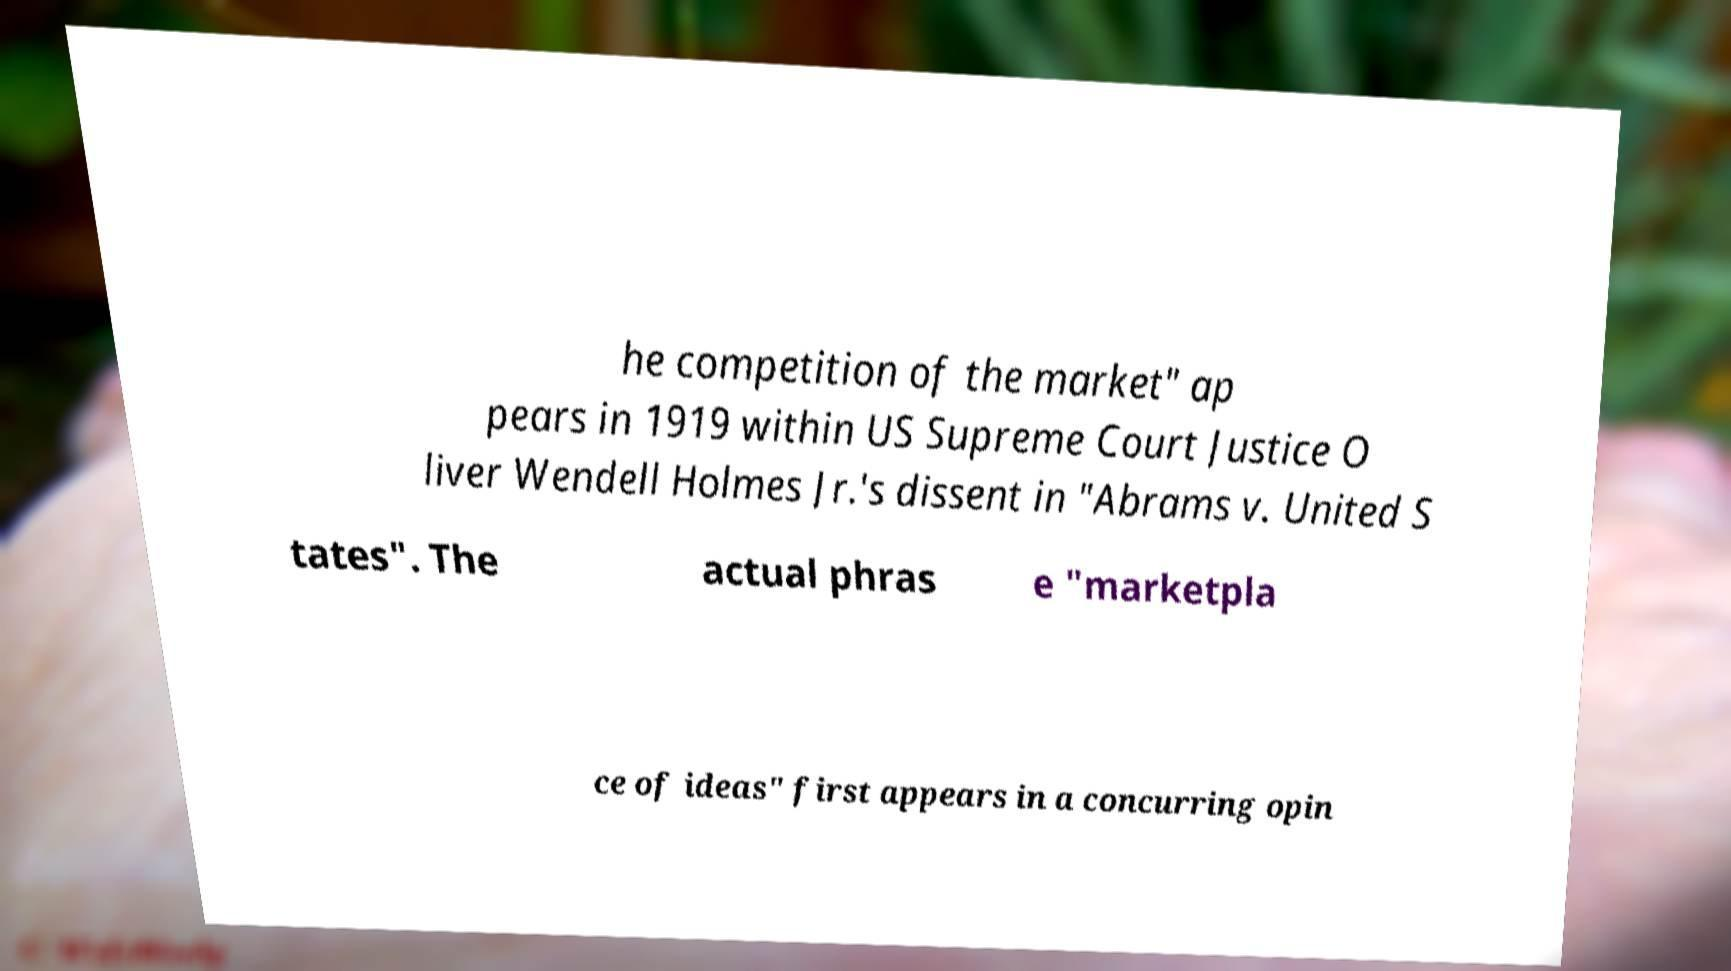Please identify and transcribe the text found in this image. he competition of the market" ap pears in 1919 within US Supreme Court Justice O liver Wendell Holmes Jr.'s dissent in "Abrams v. United S tates". The actual phras e "marketpla ce of ideas" first appears in a concurring opin 